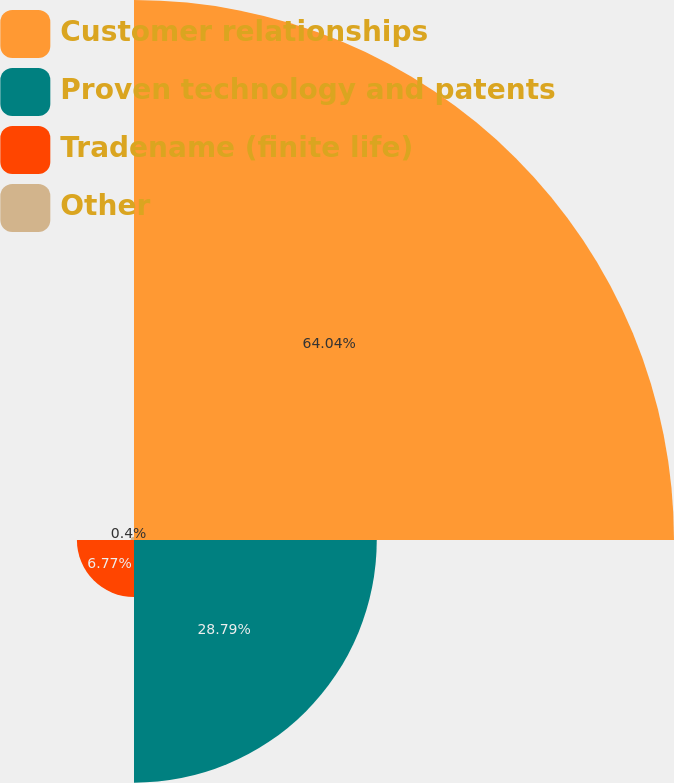Convert chart to OTSL. <chart><loc_0><loc_0><loc_500><loc_500><pie_chart><fcel>Customer relationships<fcel>Proven technology and patents<fcel>Tradename (finite life)<fcel>Other<nl><fcel>64.04%<fcel>28.79%<fcel>6.77%<fcel>0.4%<nl></chart> 